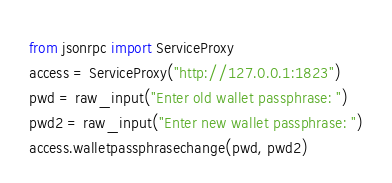Convert code to text. <code><loc_0><loc_0><loc_500><loc_500><_Python_>from jsonrpc import ServiceProxy
access = ServiceProxy("http://127.0.0.1:1823")
pwd = raw_input("Enter old wallet passphrase: ")
pwd2 = raw_input("Enter new wallet passphrase: ")
access.walletpassphrasechange(pwd, pwd2)
</code> 